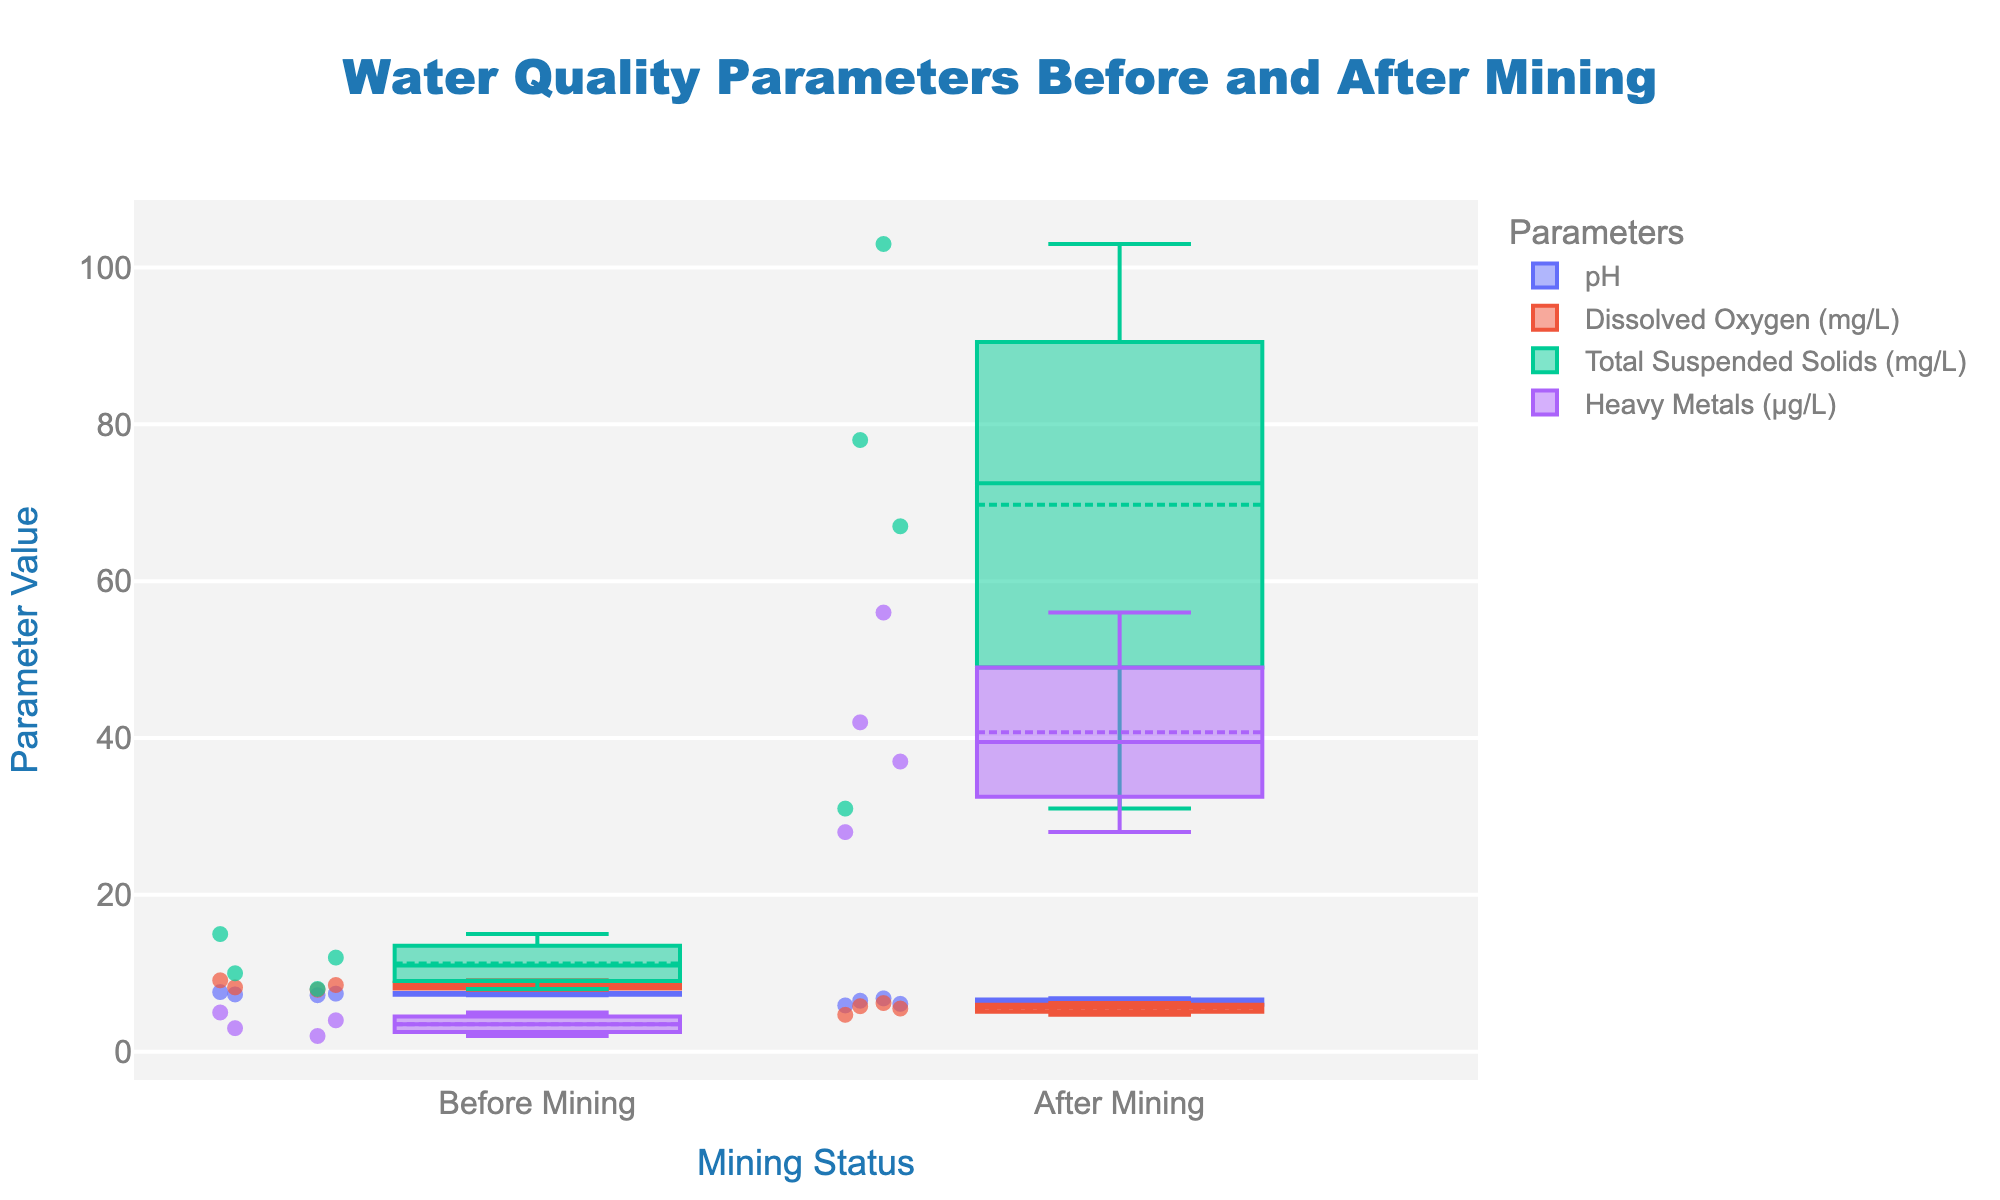What is the title of the figure? The title of the figure is placed at the top and denotes the main subject of the visualization.
Answer: Water Quality Parameters Before and After Mining What are the x-axis labels? The x-axis labels describe the categories along the horizontal axis of the Strip Plot.
Answer: Before Mining, After Mining Which parameter has the highest increase in Total Suspended Solids (mg/L) after mining activities? Look at the box plots for Total Suspended Solids (mg/L) across the water sources and compare the values before and after mining.
Answer: Sunflower River How does the pH level of Farmland Creek change after mining? Compare the pH values of Farmland Creek before and after mining operations from the respective box plots.
Answer: Decreases from 7.2 to 6.1 What is the median value of Dissolved Oxygen (mg/L) for all water sources after mining? Observe the box plot for Dissolved Oxygen (mg/L) under the "After Mining" category and find the median value.
Answer: 5.8 Which water source experienced the largest increase in Heavy Metals (μg/L) after mining? Compare the Heavy Metals (μg/L) values before and after mining for each water source and identify the one with the largest difference.
Answer: Sunflower River Among all water sources, which parameter dropped the most after mining operations? For all parameters across each water source, compare the drop in values before and after mining and identify the largest decrease.
Answer: Dissolved Oxygen (mg/L) in Sunflower River Is the distribution of water quality values generally higher before or after mining? Observe the overall spread and central tendency of the box plots before mining and after mining.
Answer: After Mining (higher values) What is the range of pH values for Harvest Pond before mining? Identify the minimum and maximum values of the box plot for pH of Harvest Pond before mining.
Answer: 7.3 How does the Dissolved Oxygen level in Green Valley Well after mining compare to Harvest Pond before mining? Compare the Dissolved Oxygen (mg/L) values of Green Valley Well after mining to Harvest Pond before mining by observing the box plots.
Answer: Green Valley Well after mining has lower values Which parameter shows the most variability after mining activities? Variability can be gauged by the spread of the box plots. Look for the widest box plots and identify the parameter.
Answer: Total Suspended Solids (mg/L) 